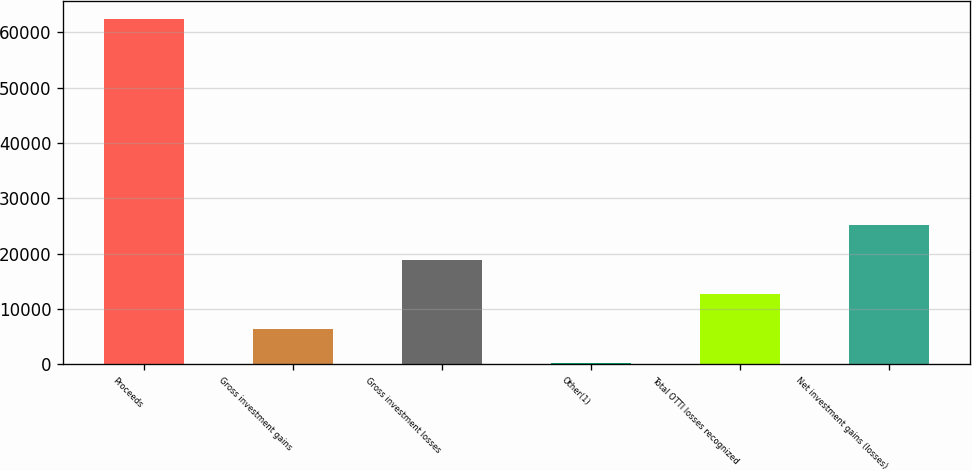Convert chart to OTSL. <chart><loc_0><loc_0><loc_500><loc_500><bar_chart><fcel>Proceeds<fcel>Gross investment gains<fcel>Gross investment losses<fcel>Other(1)<fcel>Total OTTI losses recognized<fcel>Net investment gains (losses)<nl><fcel>62495<fcel>6391.7<fcel>18859.1<fcel>158<fcel>12625.4<fcel>25092.8<nl></chart> 